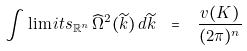<formula> <loc_0><loc_0><loc_500><loc_500>\int \lim i t s _ { { \mathbb { R } } ^ { n } } \, \widehat { \Omega } ^ { 2 } ( \widetilde { k } ) \, d \widetilde { k } \ = \ \, \frac { v ( K ) } { ( 2 \pi ) ^ { n } }</formula> 